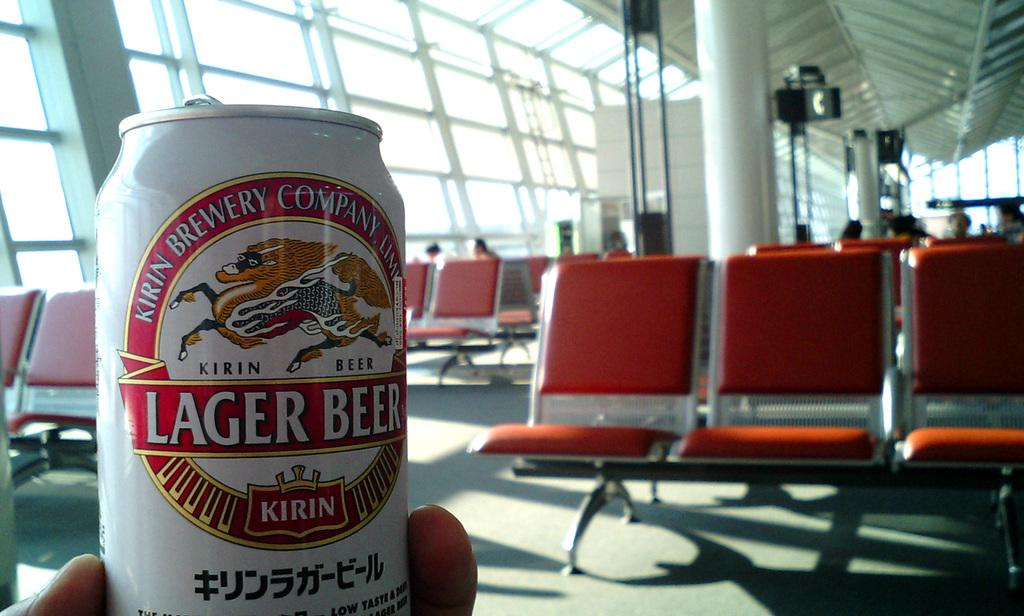<image>
Share a concise interpretation of the image provided. A can of Kirin brand Lager beer being held in a hand. 